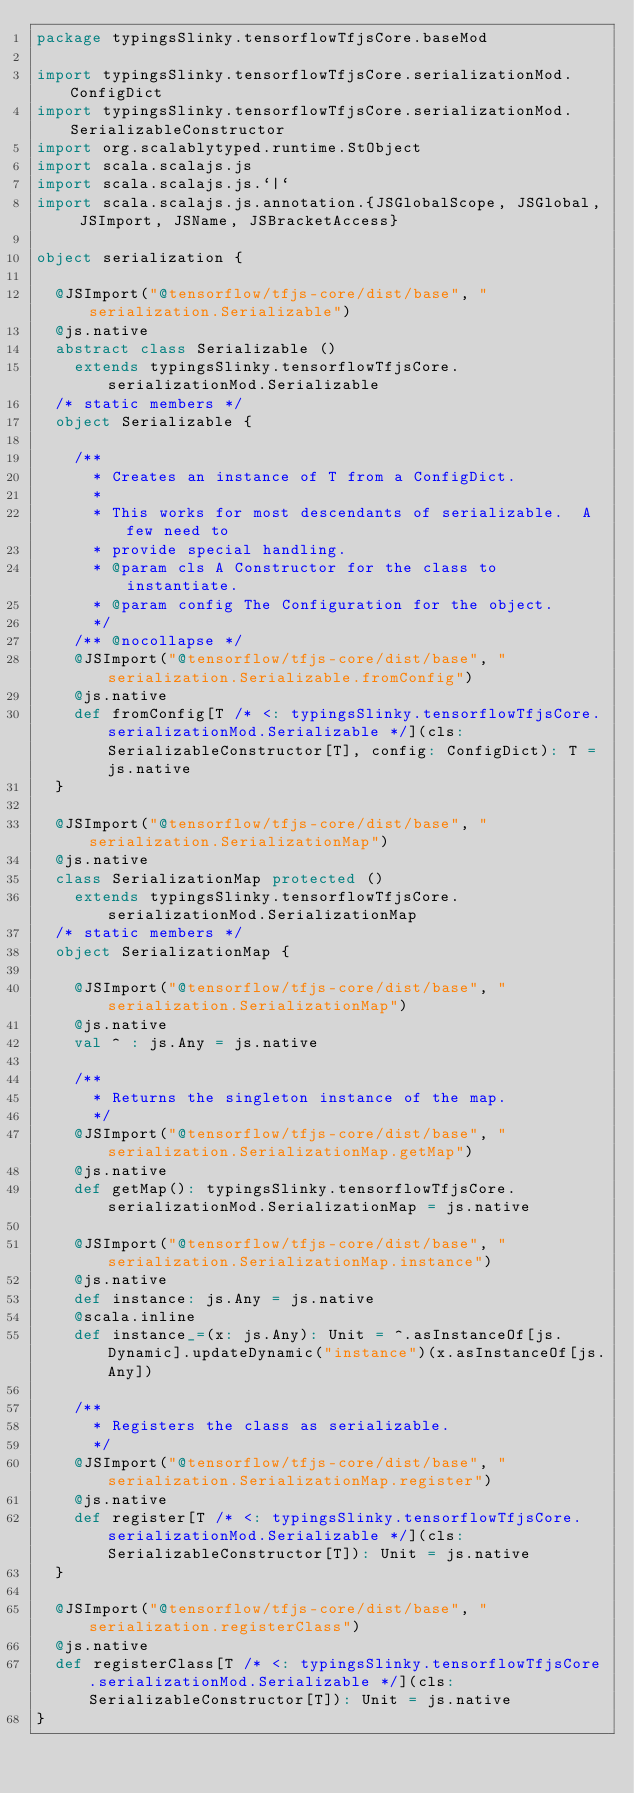Convert code to text. <code><loc_0><loc_0><loc_500><loc_500><_Scala_>package typingsSlinky.tensorflowTfjsCore.baseMod

import typingsSlinky.tensorflowTfjsCore.serializationMod.ConfigDict
import typingsSlinky.tensorflowTfjsCore.serializationMod.SerializableConstructor
import org.scalablytyped.runtime.StObject
import scala.scalajs.js
import scala.scalajs.js.`|`
import scala.scalajs.js.annotation.{JSGlobalScope, JSGlobal, JSImport, JSName, JSBracketAccess}

object serialization {
  
  @JSImport("@tensorflow/tfjs-core/dist/base", "serialization.Serializable")
  @js.native
  abstract class Serializable ()
    extends typingsSlinky.tensorflowTfjsCore.serializationMod.Serializable
  /* static members */
  object Serializable {
    
    /**
      * Creates an instance of T from a ConfigDict.
      *
      * This works for most descendants of serializable.  A few need to
      * provide special handling.
      * @param cls A Constructor for the class to instantiate.
      * @param config The Configuration for the object.
      */
    /** @nocollapse */
    @JSImport("@tensorflow/tfjs-core/dist/base", "serialization.Serializable.fromConfig")
    @js.native
    def fromConfig[T /* <: typingsSlinky.tensorflowTfjsCore.serializationMod.Serializable */](cls: SerializableConstructor[T], config: ConfigDict): T = js.native
  }
  
  @JSImport("@tensorflow/tfjs-core/dist/base", "serialization.SerializationMap")
  @js.native
  class SerializationMap protected ()
    extends typingsSlinky.tensorflowTfjsCore.serializationMod.SerializationMap
  /* static members */
  object SerializationMap {
    
    @JSImport("@tensorflow/tfjs-core/dist/base", "serialization.SerializationMap")
    @js.native
    val ^ : js.Any = js.native
    
    /**
      * Returns the singleton instance of the map.
      */
    @JSImport("@tensorflow/tfjs-core/dist/base", "serialization.SerializationMap.getMap")
    @js.native
    def getMap(): typingsSlinky.tensorflowTfjsCore.serializationMod.SerializationMap = js.native
    
    @JSImport("@tensorflow/tfjs-core/dist/base", "serialization.SerializationMap.instance")
    @js.native
    def instance: js.Any = js.native
    @scala.inline
    def instance_=(x: js.Any): Unit = ^.asInstanceOf[js.Dynamic].updateDynamic("instance")(x.asInstanceOf[js.Any])
    
    /**
      * Registers the class as serializable.
      */
    @JSImport("@tensorflow/tfjs-core/dist/base", "serialization.SerializationMap.register")
    @js.native
    def register[T /* <: typingsSlinky.tensorflowTfjsCore.serializationMod.Serializable */](cls: SerializableConstructor[T]): Unit = js.native
  }
  
  @JSImport("@tensorflow/tfjs-core/dist/base", "serialization.registerClass")
  @js.native
  def registerClass[T /* <: typingsSlinky.tensorflowTfjsCore.serializationMod.Serializable */](cls: SerializableConstructor[T]): Unit = js.native
}
</code> 